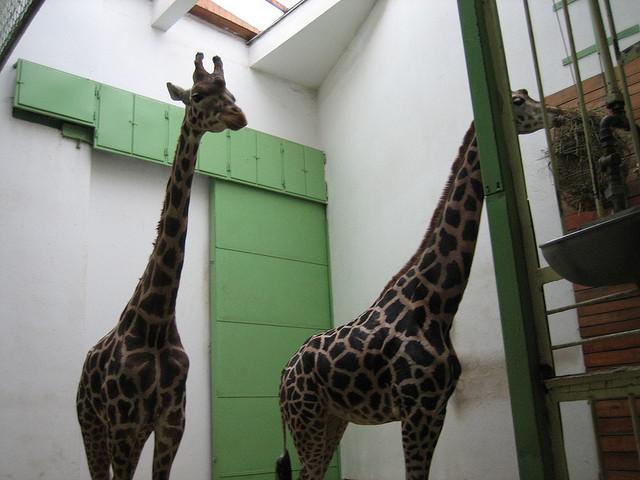How many giraffes are in the photo?
Give a very brief answer. 2. 